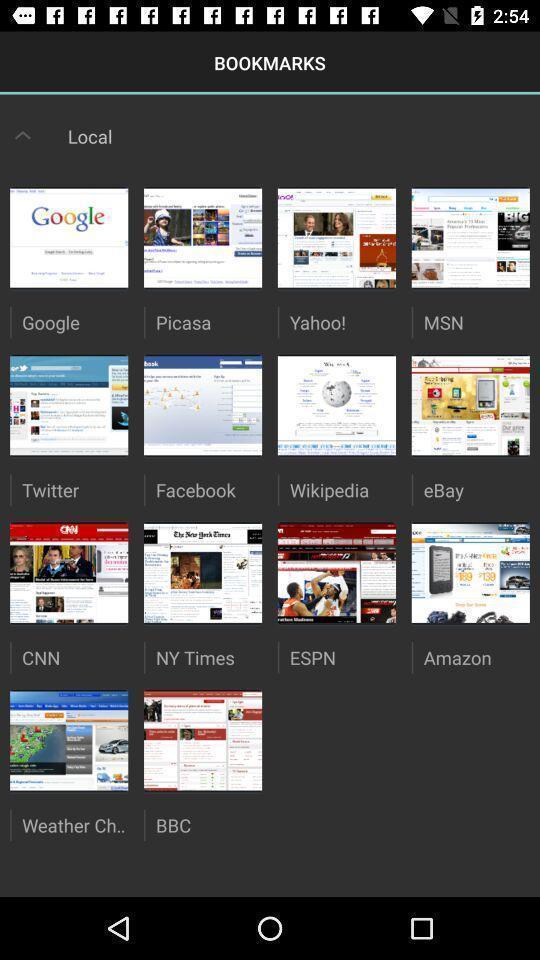Give me a narrative description of this picture. Screen displaying the book marks page. 